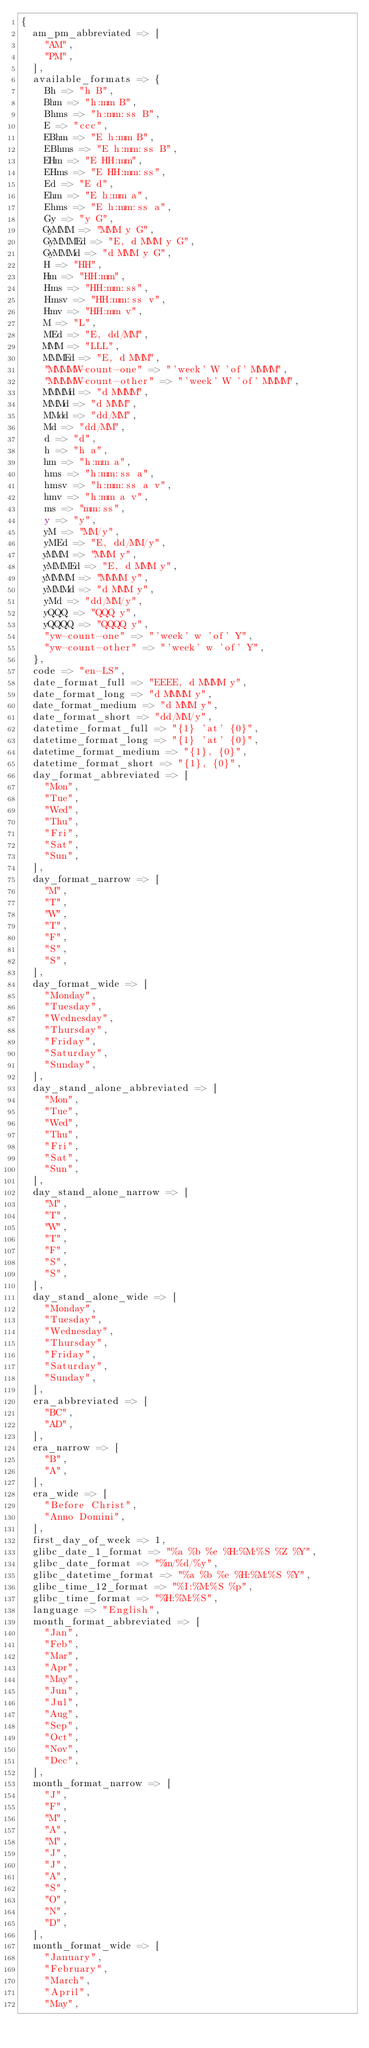Convert code to text. <code><loc_0><loc_0><loc_500><loc_500><_Perl_>{
  am_pm_abbreviated => [
    "AM",
    "PM",
  ],
  available_formats => {
    Bh => "h B",
    Bhm => "h:mm B",
    Bhms => "h:mm:ss B",
    E => "ccc",
    EBhm => "E h:mm B",
    EBhms => "E h:mm:ss B",
    EHm => "E HH:mm",
    EHms => "E HH:mm:ss",
    Ed => "E d",
    Ehm => "E h:mm a",
    Ehms => "E h:mm:ss a",
    Gy => "y G",
    GyMMM => "MMM y G",
    GyMMMEd => "E, d MMM y G",
    GyMMMd => "d MMM y G",
    H => "HH",
    Hm => "HH:mm",
    Hms => "HH:mm:ss",
    Hmsv => "HH:mm:ss v",
    Hmv => "HH:mm v",
    M => "L",
    MEd => "E, dd/MM",
    MMM => "LLL",
    MMMEd => "E, d MMM",
    "MMMMW-count-one" => "'week' W 'of' MMMM",
    "MMMMW-count-other" => "'week' W 'of' MMMM",
    MMMMd => "d MMMM",
    MMMd => "d MMM",
    MMdd => "dd/MM",
    Md => "dd/MM",
    d => "d",
    h => "h a",
    hm => "h:mm a",
    hms => "h:mm:ss a",
    hmsv => "h:mm:ss a v",
    hmv => "h:mm a v",
    ms => "mm:ss",
    y => "y",
    yM => "MM/y",
    yMEd => "E, dd/MM/y",
    yMMM => "MMM y",
    yMMMEd => "E, d MMM y",
    yMMMM => "MMMM y",
    yMMMd => "d MMM y",
    yMd => "dd/MM/y",
    yQQQ => "QQQ y",
    yQQQQ => "QQQQ y",
    "yw-count-one" => "'week' w 'of' Y",
    "yw-count-other" => "'week' w 'of' Y",
  },
  code => "en-LS",
  date_format_full => "EEEE, d MMMM y",
  date_format_long => "d MMMM y",
  date_format_medium => "d MMM y",
  date_format_short => "dd/MM/y",
  datetime_format_full => "{1} 'at' {0}",
  datetime_format_long => "{1} 'at' {0}",
  datetime_format_medium => "{1}, {0}",
  datetime_format_short => "{1}, {0}",
  day_format_abbreviated => [
    "Mon",
    "Tue",
    "Wed",
    "Thu",
    "Fri",
    "Sat",
    "Sun",
  ],
  day_format_narrow => [
    "M",
    "T",
    "W",
    "T",
    "F",
    "S",
    "S",
  ],
  day_format_wide => [
    "Monday",
    "Tuesday",
    "Wednesday",
    "Thursday",
    "Friday",
    "Saturday",
    "Sunday",
  ],
  day_stand_alone_abbreviated => [
    "Mon",
    "Tue",
    "Wed",
    "Thu",
    "Fri",
    "Sat",
    "Sun",
  ],
  day_stand_alone_narrow => [
    "M",
    "T",
    "W",
    "T",
    "F",
    "S",
    "S",
  ],
  day_stand_alone_wide => [
    "Monday",
    "Tuesday",
    "Wednesday",
    "Thursday",
    "Friday",
    "Saturday",
    "Sunday",
  ],
  era_abbreviated => [
    "BC",
    "AD",
  ],
  era_narrow => [
    "B",
    "A",
  ],
  era_wide => [
    "Before Christ",
    "Anno Domini",
  ],
  first_day_of_week => 1,
  glibc_date_1_format => "%a %b %e %H:%M:%S %Z %Y",
  glibc_date_format => "%m/%d/%y",
  glibc_datetime_format => "%a %b %e %H:%M:%S %Y",
  glibc_time_12_format => "%I:%M:%S %p",
  glibc_time_format => "%H:%M:%S",
  language => "English",
  month_format_abbreviated => [
    "Jan",
    "Feb",
    "Mar",
    "Apr",
    "May",
    "Jun",
    "Jul",
    "Aug",
    "Sep",
    "Oct",
    "Nov",
    "Dec",
  ],
  month_format_narrow => [
    "J",
    "F",
    "M",
    "A",
    "M",
    "J",
    "J",
    "A",
    "S",
    "O",
    "N",
    "D",
  ],
  month_format_wide => [
    "January",
    "February",
    "March",
    "April",
    "May",</code> 